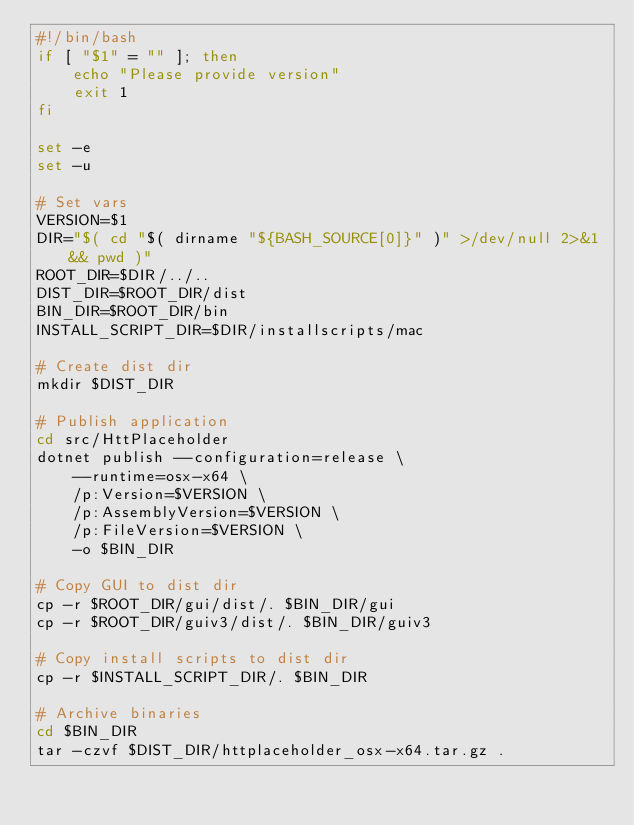Convert code to text. <code><loc_0><loc_0><loc_500><loc_500><_Bash_>#!/bin/bash
if [ "$1" = "" ]; then
    echo "Please provide version"
    exit 1
fi

set -e
set -u

# Set vars
VERSION=$1
DIR="$( cd "$( dirname "${BASH_SOURCE[0]}" )" >/dev/null 2>&1 && pwd )"
ROOT_DIR=$DIR/../..
DIST_DIR=$ROOT_DIR/dist
BIN_DIR=$ROOT_DIR/bin
INSTALL_SCRIPT_DIR=$DIR/installscripts/mac

# Create dist dir
mkdir $DIST_DIR

# Publish application
cd src/HttPlaceholder
dotnet publish --configuration=release \
    --runtime=osx-x64 \
    /p:Version=$VERSION \
    /p:AssemblyVersion=$VERSION \
    /p:FileVersion=$VERSION \
    -o $BIN_DIR
    
# Copy GUI to dist dir
cp -r $ROOT_DIR/gui/dist/. $BIN_DIR/gui
cp -r $ROOT_DIR/guiv3/dist/. $BIN_DIR/guiv3

# Copy install scripts to dist dir
cp -r $INSTALL_SCRIPT_DIR/. $BIN_DIR

# Archive binaries
cd $BIN_DIR
tar -czvf $DIST_DIR/httplaceholder_osx-x64.tar.gz .
</code> 